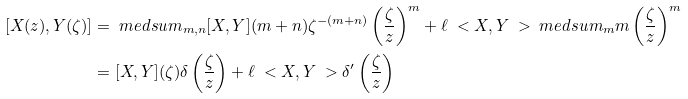Convert formula to latex. <formula><loc_0><loc_0><loc_500><loc_500>[ X ( z ) , Y ( \zeta ) ] & = \ m e d s u m _ { m , n } [ X , Y ] ( m + n ) \zeta ^ { - ( m + n ) } \left ( \frac { \zeta } { z } \right ) ^ { m } + \ell \ < X , Y \ > \ m e d s u m _ { m } m \left ( \frac { \zeta } { z } \right ) ^ { m } \\ & = [ X , Y ] ( \zeta ) \delta \left ( \frac { \zeta } { z } \right ) + \ell \ < X , Y \ > \delta ^ { \prime } \left ( \frac { \zeta } { z } \right )</formula> 